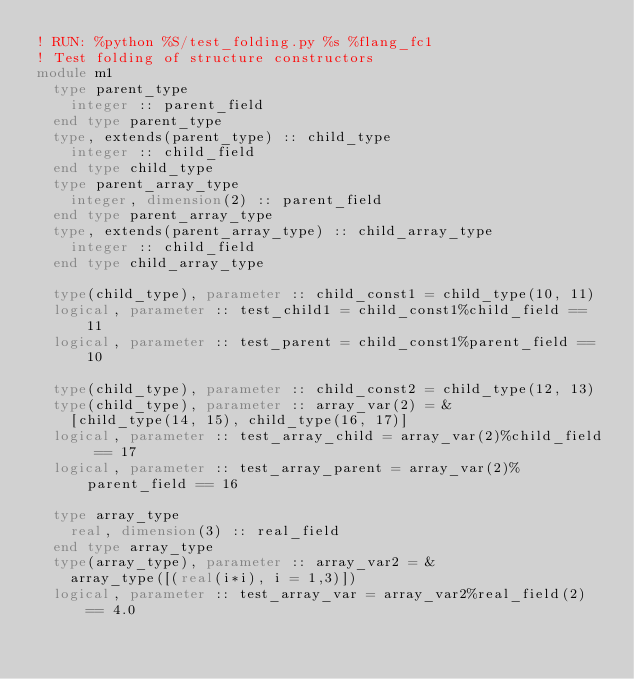Convert code to text. <code><loc_0><loc_0><loc_500><loc_500><_FORTRAN_>! RUN: %python %S/test_folding.py %s %flang_fc1
! Test folding of structure constructors
module m1
  type parent_type
    integer :: parent_field
  end type parent_type
  type, extends(parent_type) :: child_type
    integer :: child_field 
  end type child_type
  type parent_array_type
    integer, dimension(2) :: parent_field
  end type parent_array_type
  type, extends(parent_array_type) :: child_array_type
    integer :: child_field
  end type child_array_type

  type(child_type), parameter :: child_const1 = child_type(10, 11)
  logical, parameter :: test_child1 = child_const1%child_field == 11
  logical, parameter :: test_parent = child_const1%parent_field == 10

  type(child_type), parameter :: child_const2 = child_type(12, 13)
  type(child_type), parameter :: array_var(2) = &
    [child_type(14, 15), child_type(16, 17)]
  logical, parameter :: test_array_child = array_var(2)%child_field == 17 
  logical, parameter :: test_array_parent = array_var(2)%parent_field == 16

  type array_type
    real, dimension(3) :: real_field
  end type array_type
  type(array_type), parameter :: array_var2 = &
    array_type([(real(i*i), i = 1,3)])
  logical, parameter :: test_array_var = array_var2%real_field(2) == 4.0
</code> 